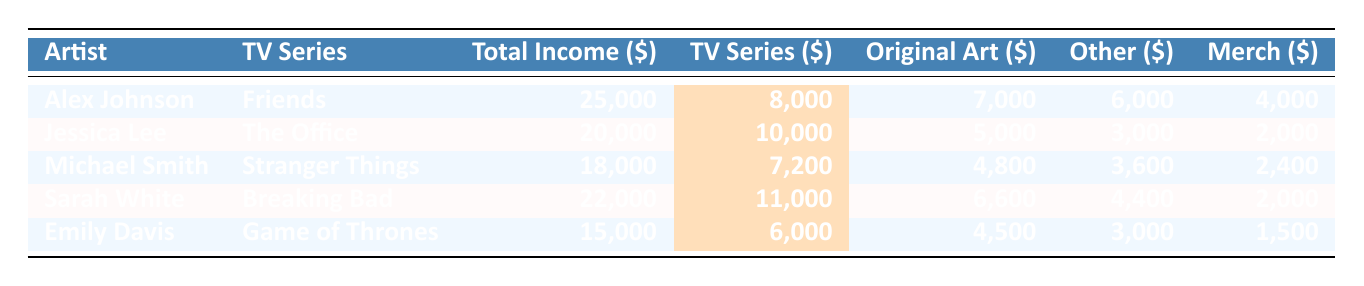What is the total income of Sarah White? From the table, Sarah White's total income is listed under the "Total Income" column, which shows 22,000.
Answer: 22,000 Which classic TV series brought in the highest income for Jessica Lee? In the "TV Series" column for Jessica Lee, the series is "The Office," which generated an income of 10,000.
Answer: The Office How much of Alex Johnson's total income comes from classic TV series commissions? Alex Johnson's classic TV series income is highlighted in the table as 8,000, which is part of his total income of 25,000.
Answer: 8,000 What percentage of Emily Davis's income comes from original art? Emily Davis's income from original art is 4,500, and her total income is 15,000. The percentage can be calculated as (4,500/15,000)*100 = 30%.
Answer: 30% Which artist has the highest income from classic TV series artwork? By comparing the classic TV series income values, Sarah White has the highest income of 11,000 coming from "Breaking Bad."
Answer: Sarah White What is the difference in total income between Michael Smith and Emily Davis? Michael Smith has a total income of 18,000, while Emily Davis has 15,000. The difference is 18,000 - 15,000 = 3,000.
Answer: 3,000 Which artist earned the least from merchandise? From the table, Emily Davis earned the least from merchandise, with an income of 1,500.
Answer: Emily Davis If we sum the classic TV series income of all artists, what is the total? Adding up the classic TV series incomes: 8,000 (Alex) + 10,000 (Jessica) + 7,200 (Michael) + 11,000 (Sarah) + 6,000 (Emily) gives us 42,200.
Answer: 42,200 What percentage of Jessica Lee's total income comes from commissions related to classic TV series? Jessica Lee earned 10,000 from classic TV series out of 20,000 total income, the percentage is (10,000/20,000)*100 = 50%.
Answer: 50% True or False: Michael Smith earned more from original art than from classic TV series commissions. The table shows Michael Smith's income from original art is 4,800, while his classic TV series commission is 7,200, which means the statement is false.
Answer: False 